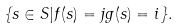Convert formula to latex. <formula><loc_0><loc_0><loc_500><loc_500>\{ s \in S | f ( s ) = j g ( s ) = i \} .</formula> 